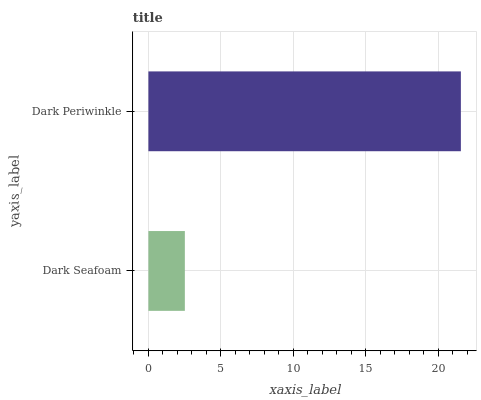Is Dark Seafoam the minimum?
Answer yes or no. Yes. Is Dark Periwinkle the maximum?
Answer yes or no. Yes. Is Dark Periwinkle the minimum?
Answer yes or no. No. Is Dark Periwinkle greater than Dark Seafoam?
Answer yes or no. Yes. Is Dark Seafoam less than Dark Periwinkle?
Answer yes or no. Yes. Is Dark Seafoam greater than Dark Periwinkle?
Answer yes or no. No. Is Dark Periwinkle less than Dark Seafoam?
Answer yes or no. No. Is Dark Periwinkle the high median?
Answer yes or no. Yes. Is Dark Seafoam the low median?
Answer yes or no. Yes. Is Dark Seafoam the high median?
Answer yes or no. No. Is Dark Periwinkle the low median?
Answer yes or no. No. 